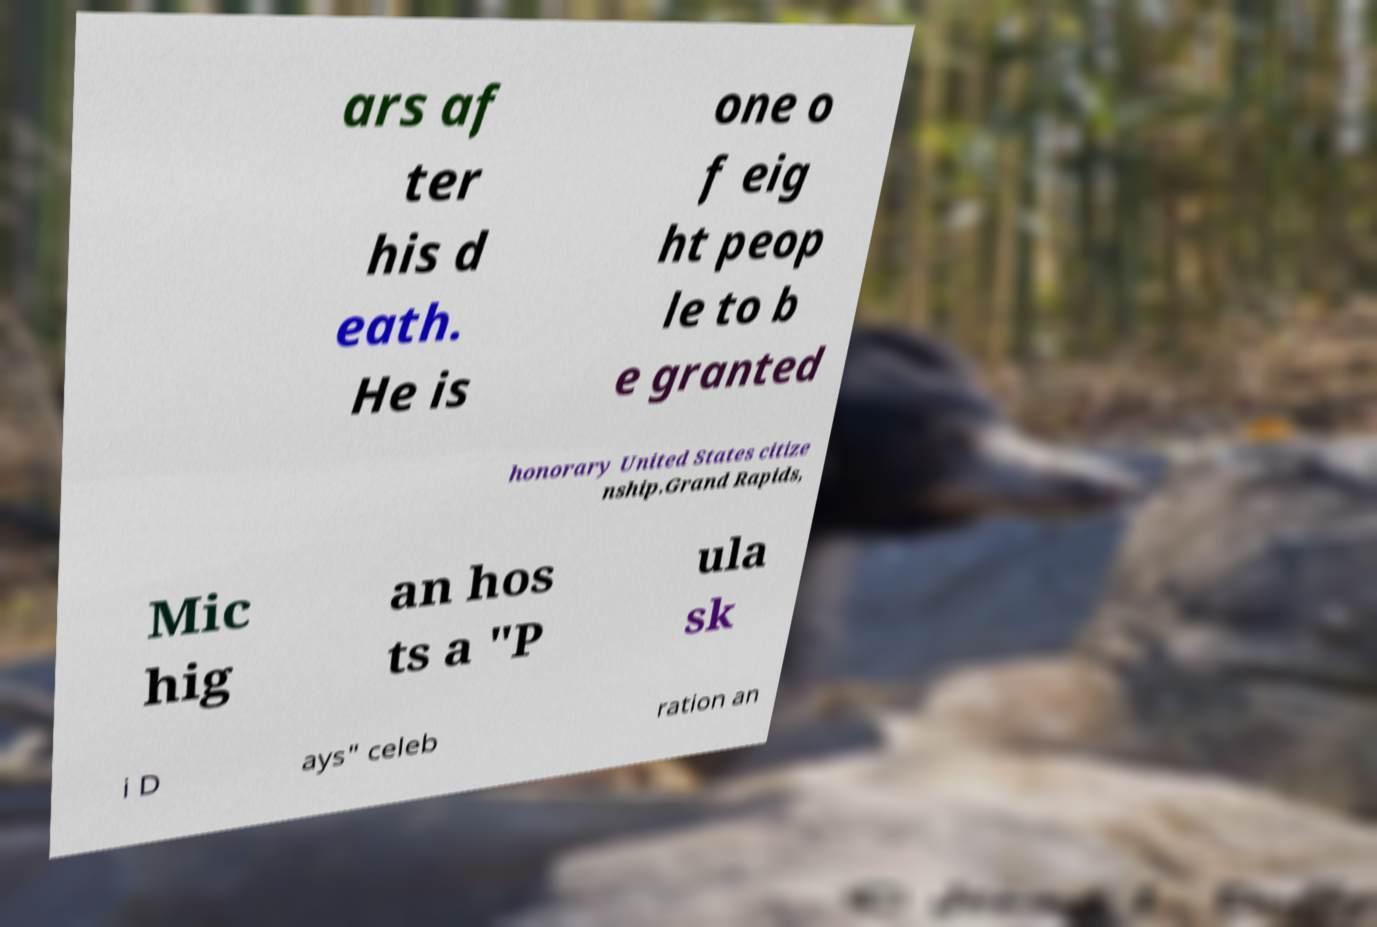Can you accurately transcribe the text from the provided image for me? ars af ter his d eath. He is one o f eig ht peop le to b e granted honorary United States citize nship.Grand Rapids, Mic hig an hos ts a "P ula sk i D ays" celeb ration an 